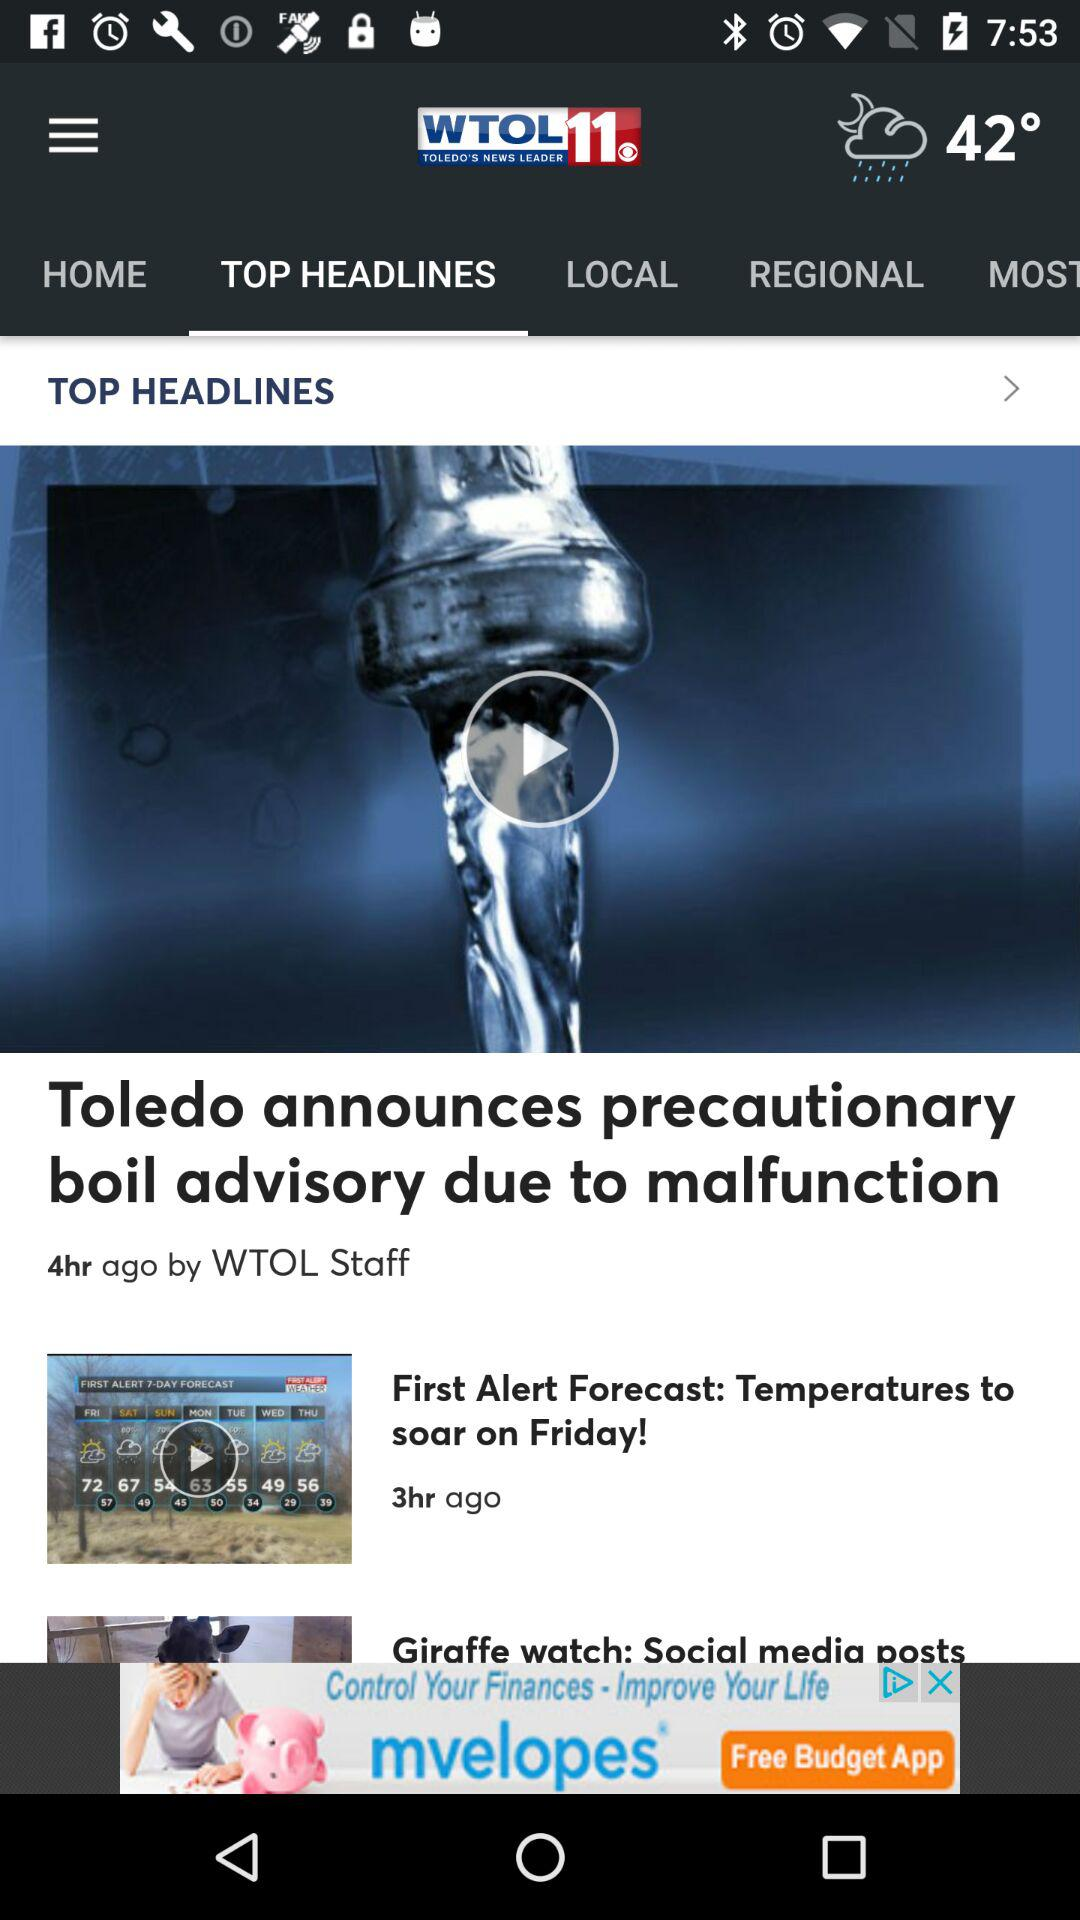Which tab am I using? You are using the "TOP HEADLINES" tab. 